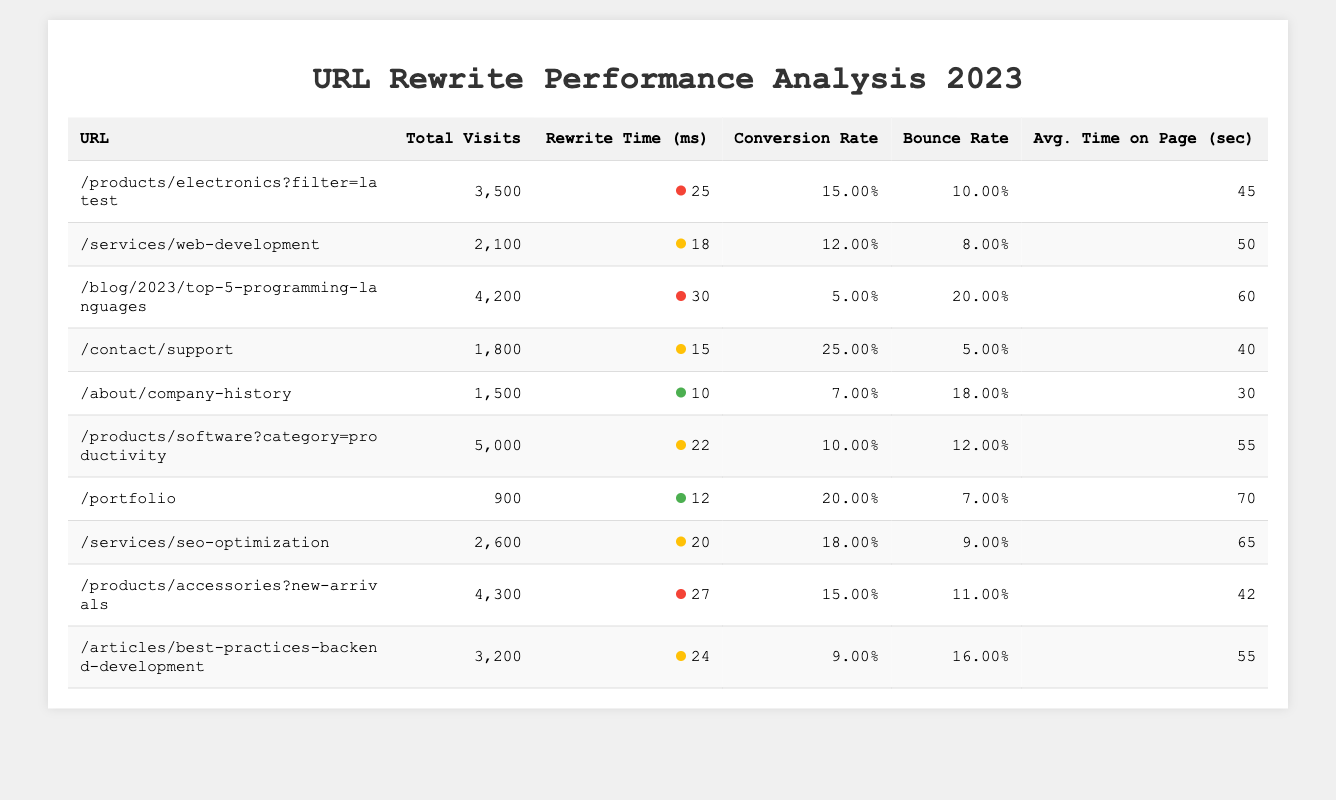What is the URL with the highest total visits? The URL with the highest total visits can be found by looking for the maximum value in the "Total Visits" column. The highest total visits recorded is 5,000 for the URL "/products/software?category=productivity".
Answer: /products/software?category=productivity Which URL has the lowest conversion rate? To find the URL with the lowest conversion rate, we compare the "Conversion Rate" figures. The minimum conversion rate is 5% for the URL "/blog/2023/top-5-programming-languages".
Answer: /blog/2023/top-5-programming-languages What is the average bounce rate of all URLs listed? We need to add all the bounce rates together and divide by the number of URLs. The bounce rates summed up are 0.10 + 0.08 + 0.20 + 0.05 + 0.18 + 0.12 + 0.07 + 0.09 + 0.11 + 0.16 = 1.16. Dividing this by 10 gives an average bounce rate of 1.16 / 10 = 0.116 or 11.6%.
Answer: 11.6% Is the average time on the page for the "/products/accessories?new-arrivals" URL greater than 40 seconds? The average time on the page for the URL "/products/accessories?new-arrivals" is listed as 42 seconds. Since 42 is greater than 40, the answer is yes.
Answer: Yes Which URL has the highest average time on page? Identify the highest value in the "Avg. Time on Page" column. The maximum is 70 seconds for the URL "/portfolio".
Answer: /portfolio What is the total number of visits for URLs with a rewrite time less than 20 ms? We check each URL's rewrite time and include only those with times less than 20 ms: "/contact/support" (1,800 visits), "/about/company-history" (1,500 visits), and "/portfolio" (900 visits). The total is 1,800 + 1,500 + 900 = 4,200 visits.
Answer: 4,200 Does the URL "/services/seo-optimization" have a bounce rate lower than 10%? The bounce rate for "/services/seo-optimization" is 9%, which is less than 10%. Thus, the answer is yes.
Answer: Yes Which URL with the maximum total visits has a rewrite time greater than 25 ms? The URL with the maximum visits is "/products/software?category=productivity" with 5,000 visits and a rewrite time of 22 ms, which is not greater than 25 ms. The next highest is "/products/accessories?new-arrivals" with 4,300 visits and a rewrite time of 27 ms.
Answer: /products/accessories?new-arrivals What is the difference in conversion rates between the URLs with the highest and lowest conversion rates? The highest conversion rate is 25% for "/contact/support" and the lowest is 5% for "/blog/2023/top-5-programming-languages". The difference is 25% - 5% = 20%.
Answer: 20% How many URLs have a rewrite time of 20 ms or less? Check the "Rewrite Time" entries and count those 20 ms or less, which are: "/contact/support" (15 ms), "/about/company-history" (10 ms), and "/portfolio" (12 ms). This gives us a total of 3 URLs.
Answer: 3 